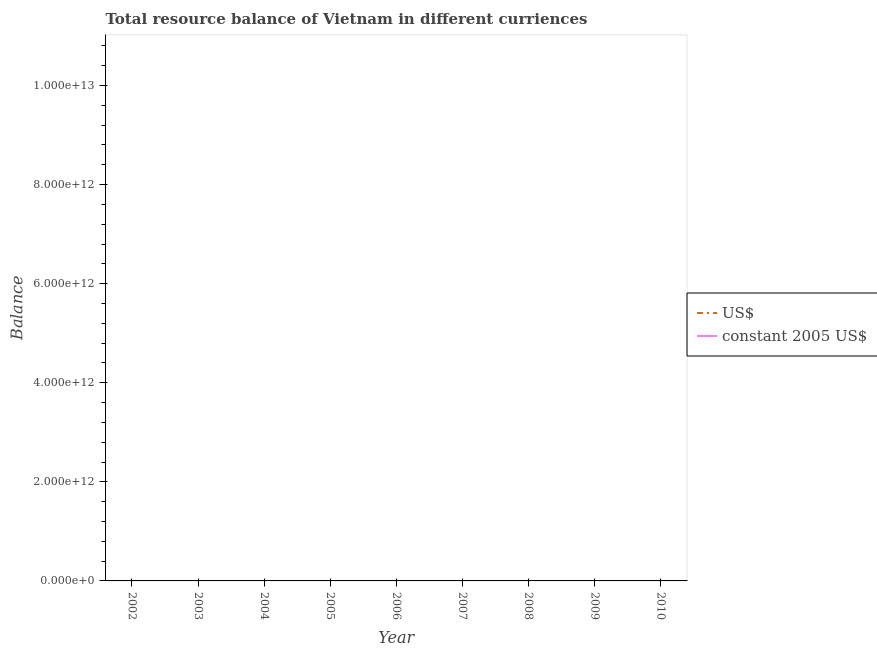Is the number of lines equal to the number of legend labels?
Offer a very short reply. No. What is the resource balance in constant us$ in 2007?
Offer a terse response. 0. What is the total resource balance in constant us$ in the graph?
Provide a short and direct response. 0. What is the difference between the resource balance in us$ in 2009 and the resource balance in constant us$ in 2006?
Provide a succinct answer. 0. Does the resource balance in constant us$ monotonically increase over the years?
Your answer should be very brief. No. Is the resource balance in us$ strictly less than the resource balance in constant us$ over the years?
Provide a short and direct response. No. How many lines are there?
Provide a succinct answer. 0. What is the difference between two consecutive major ticks on the Y-axis?
Your answer should be very brief. 2.00e+12. Are the values on the major ticks of Y-axis written in scientific E-notation?
Offer a very short reply. Yes. Does the graph contain any zero values?
Provide a short and direct response. Yes. How are the legend labels stacked?
Your answer should be very brief. Vertical. What is the title of the graph?
Give a very brief answer. Total resource balance of Vietnam in different curriences. What is the label or title of the Y-axis?
Your response must be concise. Balance. What is the Balance of US$ in 2002?
Provide a succinct answer. 0. What is the Balance of constant 2005 US$ in 2002?
Your answer should be compact. 0. What is the Balance in constant 2005 US$ in 2003?
Offer a terse response. 0. What is the Balance in US$ in 2004?
Your response must be concise. 0. What is the Balance of constant 2005 US$ in 2004?
Your answer should be very brief. 0. What is the Balance of constant 2005 US$ in 2007?
Make the answer very short. 0. What is the Balance in US$ in 2008?
Provide a short and direct response. 0. What is the Balance in constant 2005 US$ in 2008?
Your answer should be compact. 0. What is the Balance in constant 2005 US$ in 2009?
Ensure brevity in your answer.  0. What is the Balance in US$ in 2010?
Provide a succinct answer. 0. What is the average Balance in US$ per year?
Your response must be concise. 0. 